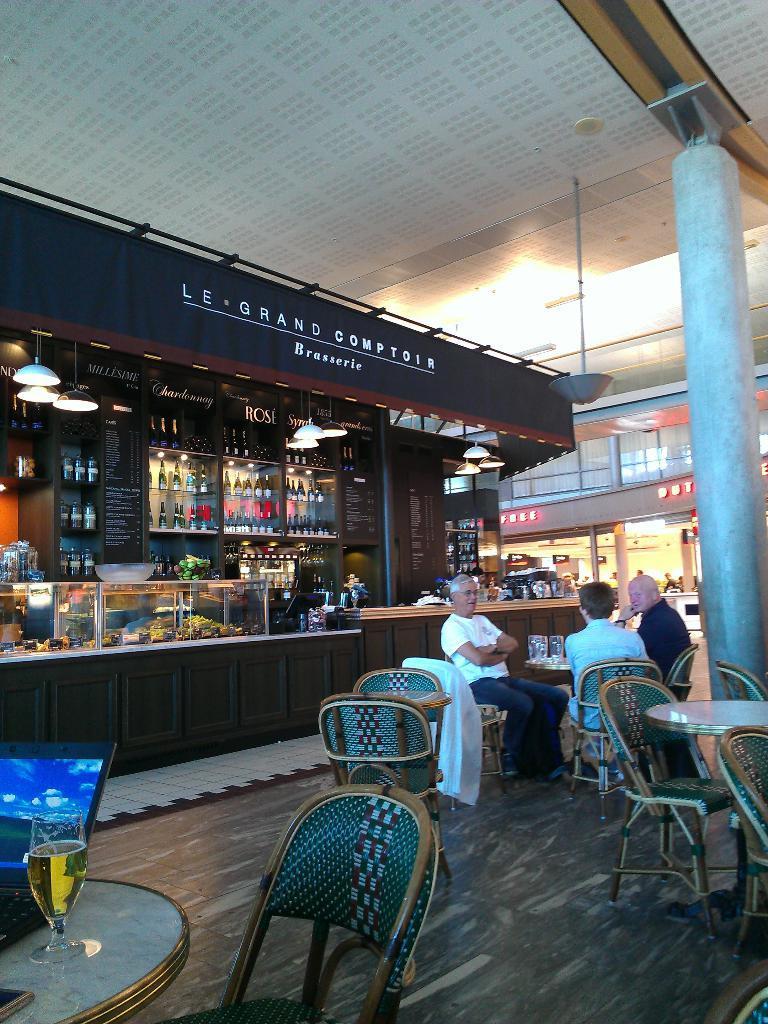Can you describe this image briefly? This is a cafeteria where we can see some chairs, tables and also three people in the picture. On the table we have a glass, laptop and some things and to the left corner we have a rack and the shelves on which the things are placed and there are some lamps in the picture and a pillar which is in the right side. 